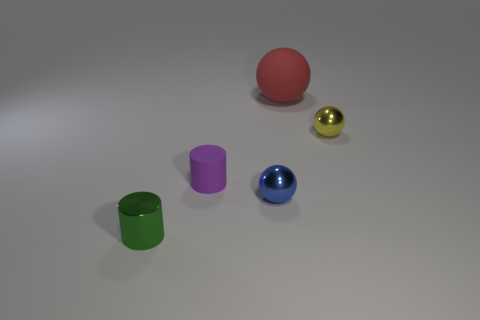Subtract all yellow balls. How many balls are left? 2 Subtract 1 balls. How many balls are left? 2 Add 1 tiny rubber cylinders. How many objects exist? 6 Subtract all purple spheres. Subtract all green cubes. How many spheres are left? 3 Subtract all balls. How many objects are left? 2 Add 3 blue metal things. How many blue metal things exist? 4 Subtract 1 yellow balls. How many objects are left? 4 Subtract all big brown balls. Subtract all blue spheres. How many objects are left? 4 Add 2 large red rubber things. How many large red rubber things are left? 3 